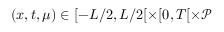Convert formula to latex. <formula><loc_0><loc_0><loc_500><loc_500>( x , t , \mu ) \in [ - L / 2 , L / 2 [ \times [ 0 , T [ \times \mathcal { P }</formula> 